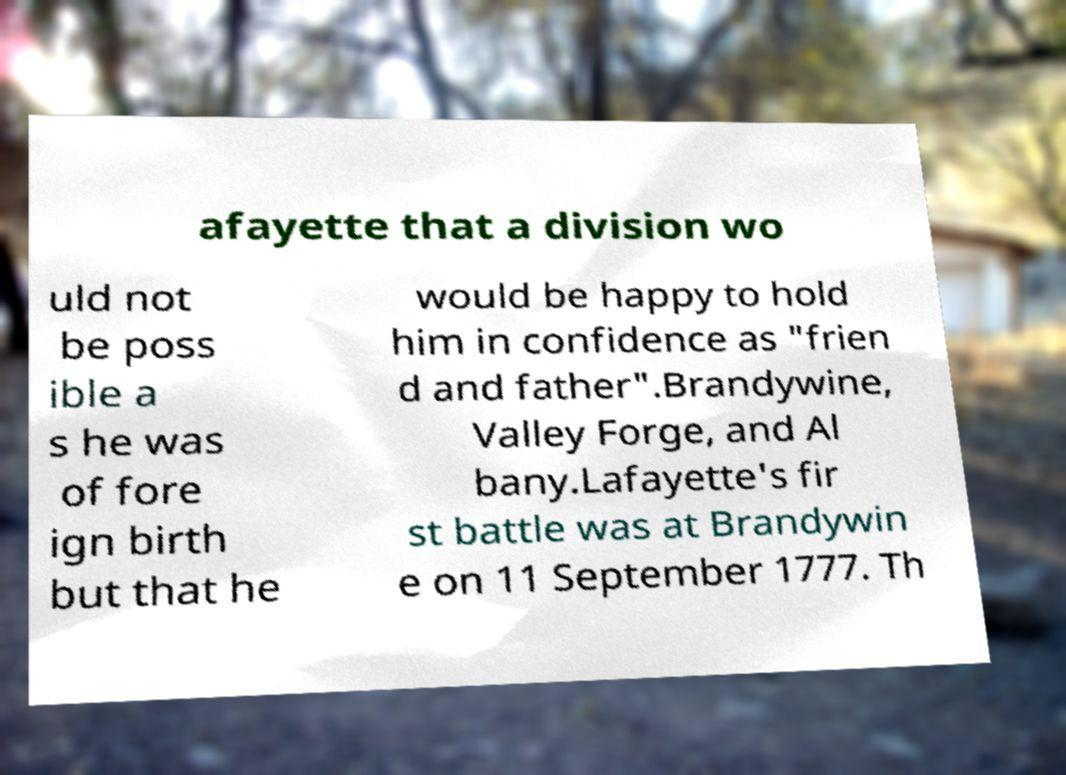I need the written content from this picture converted into text. Can you do that? afayette that a division wo uld not be poss ible a s he was of fore ign birth but that he would be happy to hold him in confidence as "frien d and father".Brandywine, Valley Forge, and Al bany.Lafayette's fir st battle was at Brandywin e on 11 September 1777. Th 